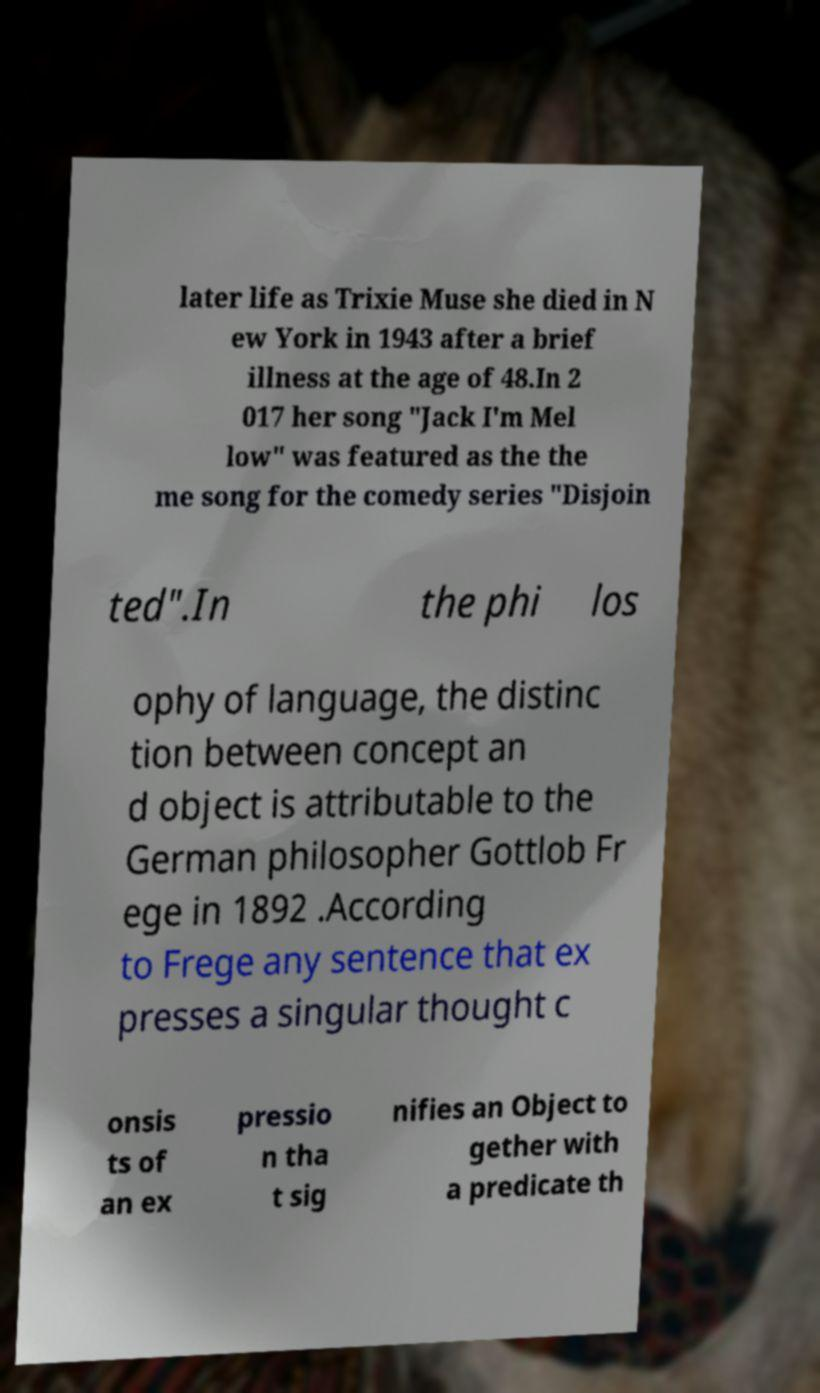Can you read and provide the text displayed in the image?This photo seems to have some interesting text. Can you extract and type it out for me? later life as Trixie Muse she died in N ew York in 1943 after a brief illness at the age of 48.In 2 017 her song "Jack I'm Mel low" was featured as the the me song for the comedy series "Disjoin ted".In the phi los ophy of language, the distinc tion between concept an d object is attributable to the German philosopher Gottlob Fr ege in 1892 .According to Frege any sentence that ex presses a singular thought c onsis ts of an ex pressio n tha t sig nifies an Object to gether with a predicate th 